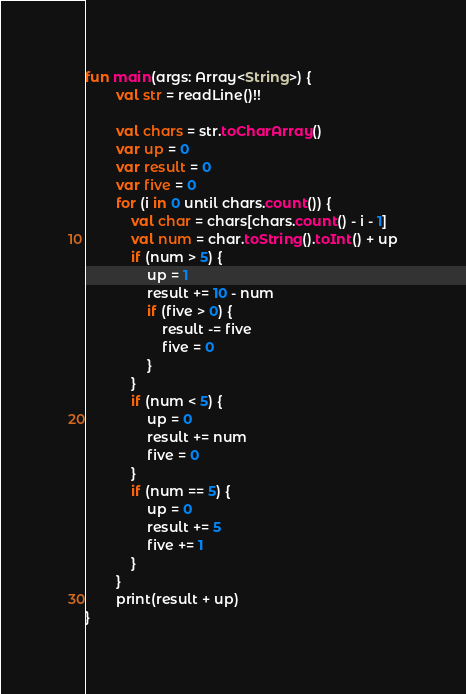Convert code to text. <code><loc_0><loc_0><loc_500><loc_500><_Kotlin_>fun main(args: Array<String>) {
        val str = readLine()!!

        val chars = str.toCharArray()
        var up = 0
        var result = 0
        var five = 0
        for (i in 0 until chars.count()) {
            val char = chars[chars.count() - i - 1]
            val num = char.toString().toInt() + up
            if (num > 5) {
                up = 1
                result += 10 - num
                if (five > 0) {
                    result -= five
                    five = 0
                }
            }
            if (num < 5) {
                up = 0
                result += num
                five = 0
            }
            if (num == 5) {
                up = 0
                result += 5
                five += 1
            }
        }
        print(result + up)
}</code> 